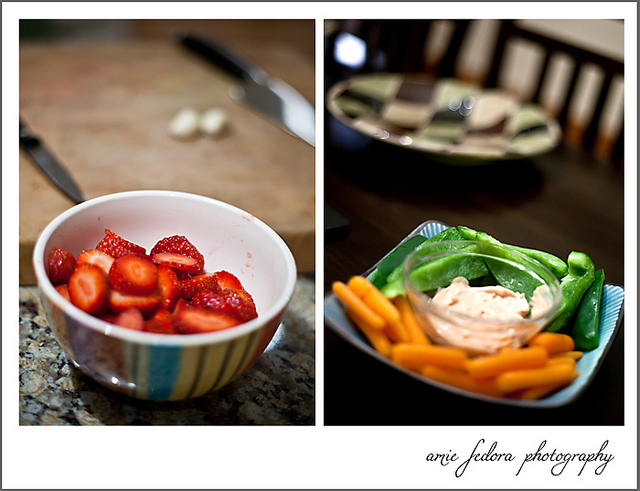Extract all visible text content from this image. amie fedore photography 